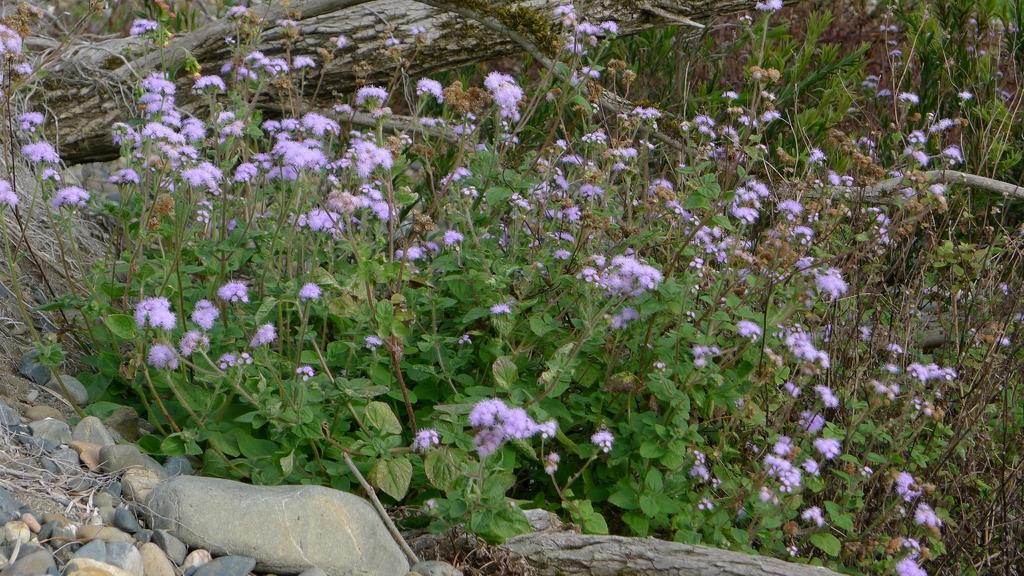What type of objects can be seen on the left side of the image? There are stones on the left side of the image. What kind of vegetation is present in the image? There are flowers on plants in the image. What type of jelly can be seen dripping from the flowers in the image? There is no jelly present in the image; it features stones and flowers on plants. How does the drain affect the appearance of the flowers in the image? There is no drain present in the image, so its effect on the flowers cannot be determined. 